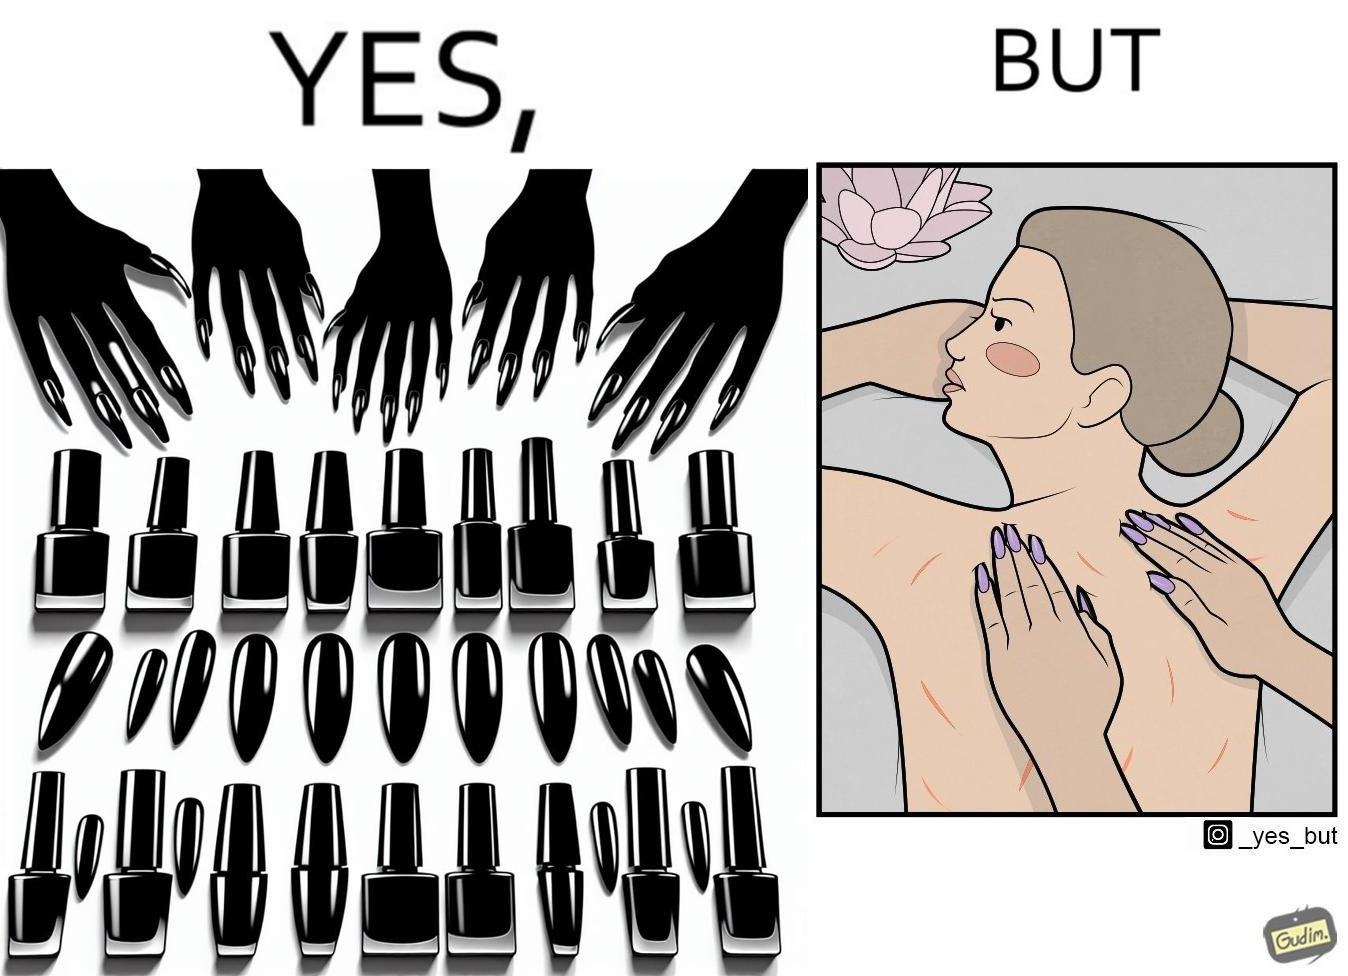What is the satirical meaning behind this image? The images are funny since it shows that even though the polished and colorful long nails look pretty and fashionable, the hinder the masseuse's ability to do her job of providing relaxing massages and hurts her customers 